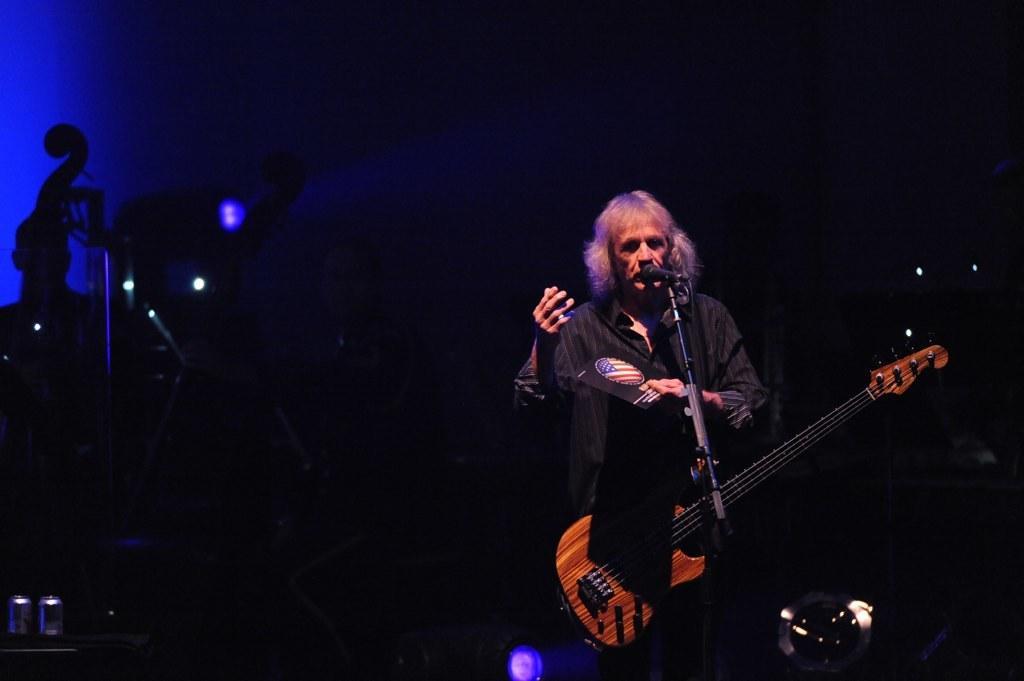Describe this image in one or two sentences. In this image i can see a person, holding a guitar and in front of him there is a mike 